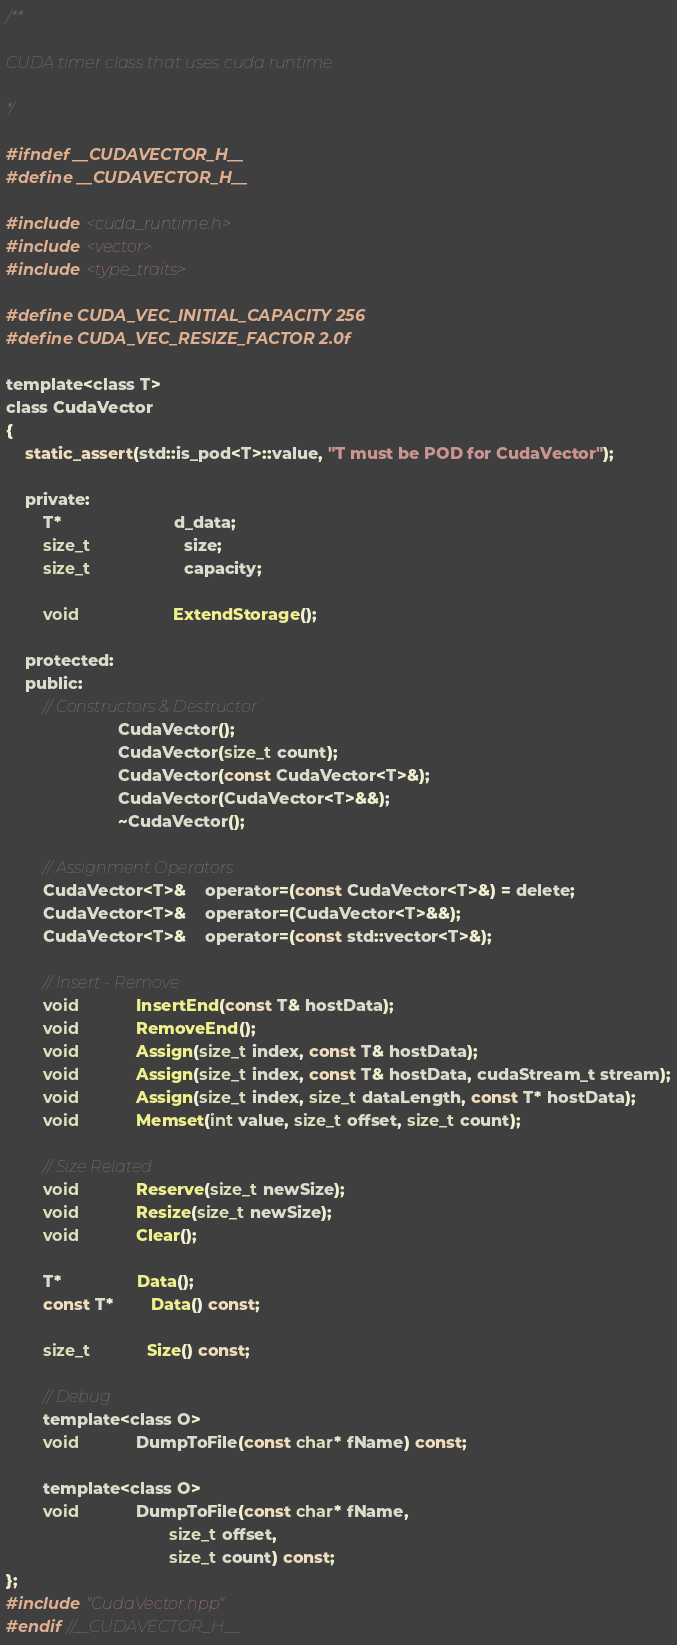<code> <loc_0><loc_0><loc_500><loc_500><_Cuda_>/**

CUDA timer class that uses cuda runtime

*/

#ifndef __CUDAVECTOR_H__
#define __CUDAVECTOR_H__

#include <cuda_runtime.h>
#include <vector>
#include <type_traits>

#define CUDA_VEC_INITIAL_CAPACITY 256
#define CUDA_VEC_RESIZE_FACTOR 2.0f

template<class T>
class CudaVector
{
	static_assert(std::is_pod<T>::value, "T must be POD for CudaVector");

	private:
		T*						d_data;
		size_t					size;
		size_t					capacity;

		void					ExtendStorage();

	protected:
	public:
		// Constructors & Destructor
						CudaVector();
						CudaVector(size_t count);
						CudaVector(const CudaVector<T>&);
						CudaVector(CudaVector<T>&&);
						~CudaVector();

		// Assignment Operators
		CudaVector<T>&	operator=(const CudaVector<T>&) = delete;
		CudaVector<T>&	operator=(CudaVector<T>&&);
		CudaVector<T>&	operator=(const std::vector<T>&);

		// Insert - Remove
		void			InsertEnd(const T& hostData);
		void			RemoveEnd();
		void			Assign(size_t index, const T& hostData);
		void			Assign(size_t index, const T& hostData, cudaStream_t stream);
		void			Assign(size_t index, size_t dataLength, const T* hostData);
		void			Memset(int value, size_t offset, size_t count);

		// Size Related
		void			Reserve(size_t newSize);
		void			Resize(size_t newSize);
		void			Clear();

		T*				Data();
		const T*		Data() const;
		
		size_t			Size() const;

		// Debug
		template<class O>
		void			DumpToFile(const char* fName) const;

		template<class O>
		void			DumpToFile(const char* fName,
								   size_t offset,
								   size_t count) const;
};
#include "CudaVector.hpp"
#endif //__CUDAVECTOR_H__</code> 